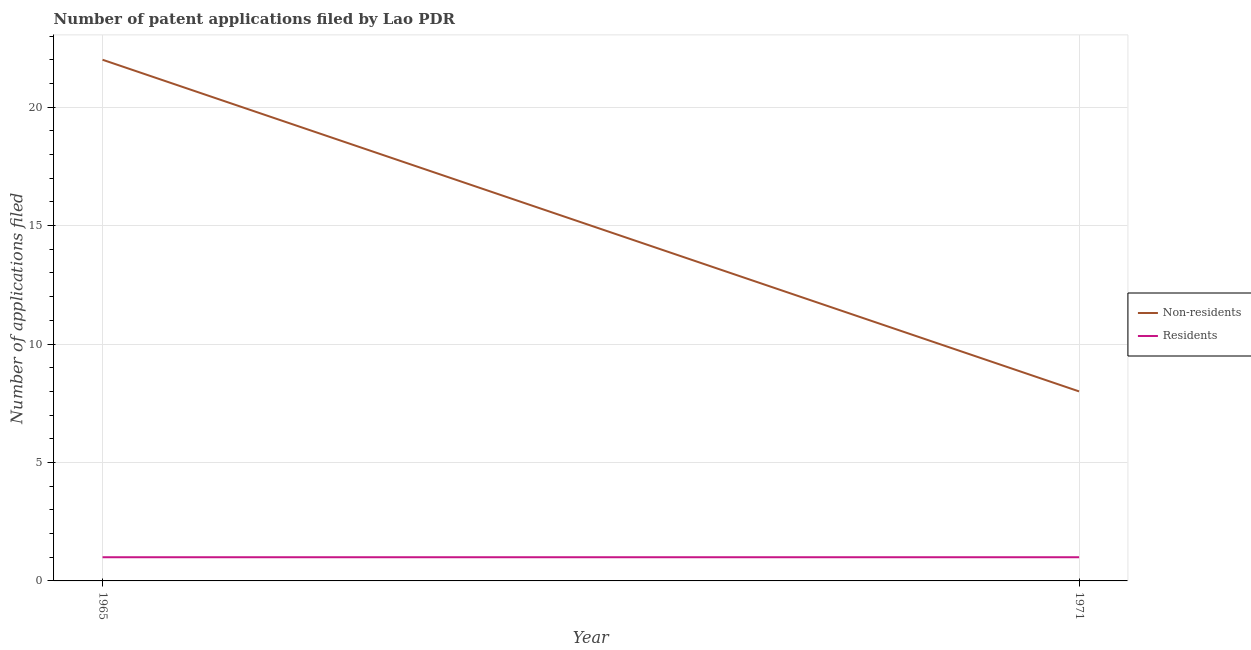Does the line corresponding to number of patent applications by residents intersect with the line corresponding to number of patent applications by non residents?
Provide a short and direct response. No. What is the number of patent applications by residents in 1965?
Provide a succinct answer. 1. Across all years, what is the maximum number of patent applications by residents?
Offer a very short reply. 1. Across all years, what is the minimum number of patent applications by non residents?
Your answer should be compact. 8. In which year was the number of patent applications by residents maximum?
Provide a succinct answer. 1965. In which year was the number of patent applications by non residents minimum?
Make the answer very short. 1971. What is the total number of patent applications by residents in the graph?
Your answer should be compact. 2. What is the difference between the number of patent applications by residents in 1965 and that in 1971?
Offer a very short reply. 0. What is the difference between the number of patent applications by residents in 1971 and the number of patent applications by non residents in 1965?
Provide a short and direct response. -21. What is the average number of patent applications by non residents per year?
Your response must be concise. 15. In the year 1965, what is the difference between the number of patent applications by non residents and number of patent applications by residents?
Provide a succinct answer. 21. Is the number of patent applications by non residents strictly greater than the number of patent applications by residents over the years?
Your answer should be very brief. Yes. How many years are there in the graph?
Ensure brevity in your answer.  2. Does the graph contain any zero values?
Offer a terse response. No. Where does the legend appear in the graph?
Provide a short and direct response. Center right. How are the legend labels stacked?
Offer a very short reply. Vertical. What is the title of the graph?
Give a very brief answer. Number of patent applications filed by Lao PDR. Does "GDP" appear as one of the legend labels in the graph?
Your answer should be very brief. No. What is the label or title of the X-axis?
Give a very brief answer. Year. What is the label or title of the Y-axis?
Provide a short and direct response. Number of applications filed. What is the Number of applications filed of Non-residents in 1971?
Your answer should be compact. 8. What is the Number of applications filed in Residents in 1971?
Your response must be concise. 1. Across all years, what is the maximum Number of applications filed of Non-residents?
Your answer should be very brief. 22. Across all years, what is the minimum Number of applications filed in Residents?
Your answer should be compact. 1. What is the difference between the Number of applications filed of Non-residents in 1965 and the Number of applications filed of Residents in 1971?
Keep it short and to the point. 21. What is the ratio of the Number of applications filed of Non-residents in 1965 to that in 1971?
Provide a short and direct response. 2.75. What is the difference between the highest and the lowest Number of applications filed of Non-residents?
Offer a very short reply. 14. 